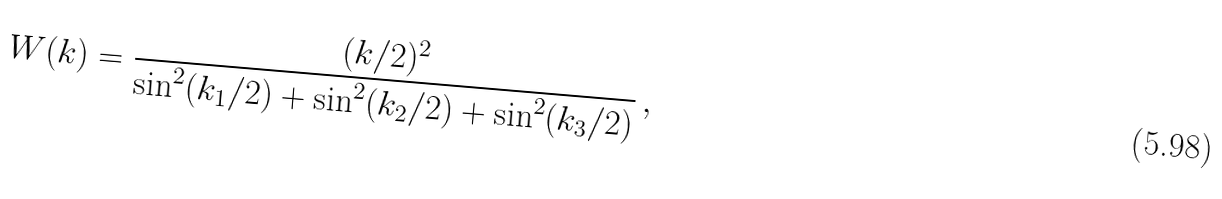<formula> <loc_0><loc_0><loc_500><loc_500>W ( { k } ) = \frac { ( k / 2 ) ^ { 2 } } { \sin ^ { 2 } ( k _ { 1 } / 2 ) + \sin ^ { 2 } ( k _ { 2 } / 2 ) + \sin ^ { 2 } ( k _ { 3 } / 2 ) } \, ,</formula> 